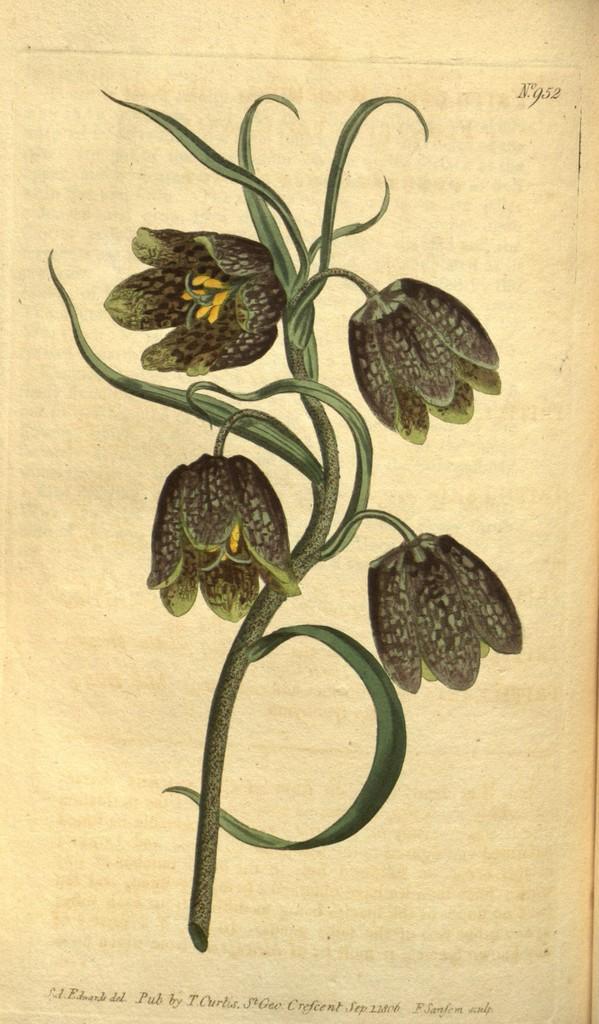In one or two sentences, can you explain what this image depicts? In this image we can see a page of a book. On the page we can see flowers and stems picture with some text. 